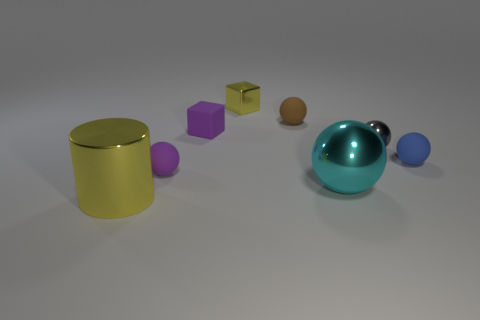How many blue metal objects have the same shape as the small gray metal thing?
Offer a terse response. 0. What is the color of the rubber ball left of the yellow thing behind the gray shiny thing?
Your response must be concise. Purple. Is the number of small matte spheres that are behind the small gray ball the same as the number of large yellow metallic objects?
Keep it short and to the point. Yes. Is there a red rubber sphere that has the same size as the gray thing?
Offer a very short reply. No. There is a blue rubber ball; is its size the same as the metal thing behind the gray shiny thing?
Give a very brief answer. Yes. Is the number of large metallic things to the right of the large cylinder the same as the number of spheres that are on the left side of the metallic block?
Keep it short and to the point. Yes. What shape is the rubber thing that is the same color as the rubber block?
Offer a very short reply. Sphere. There is a small thing in front of the blue ball; what material is it?
Provide a short and direct response. Rubber. Do the brown rubber object and the cyan thing have the same size?
Make the answer very short. No. Are there more yellow shiny objects behind the tiny brown sphere than tiny blue metallic things?
Offer a very short reply. Yes. 